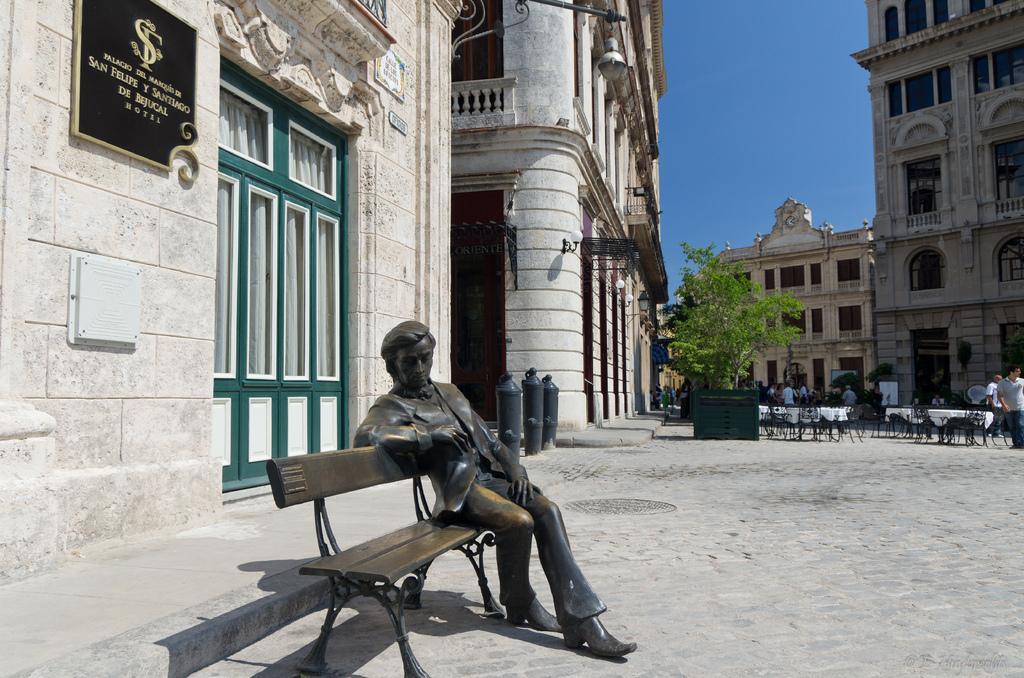Describe this image in one or two sentences. In this image i can see a statue sitting on the bench at left there is a wall, a board and a window in green color at the back ground ii can see a tree, a sky few other persons walking on the road. 